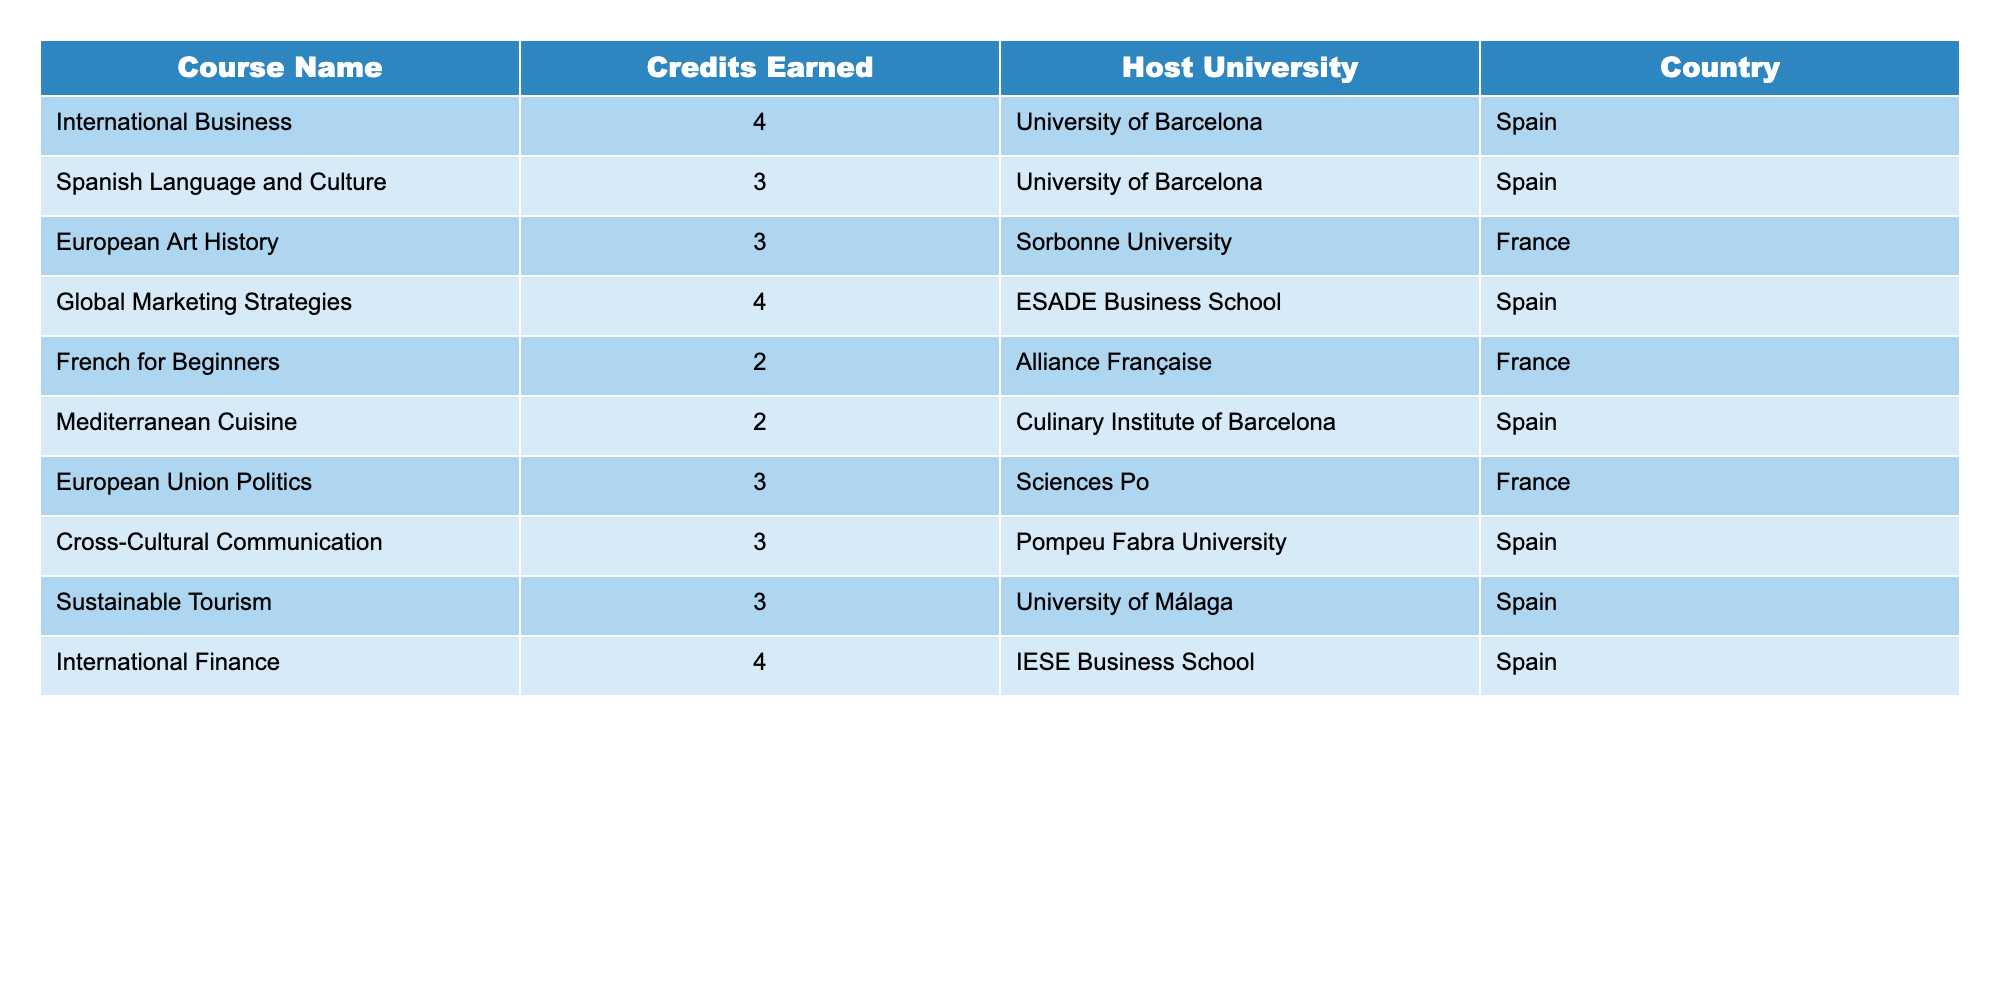What is the total number of credits earned for courses taken in Spain? The table shows courses taken in Spain with their respective credits. The relevant courses are: International Business (4), Spanish Language and Culture (3), Global Marketing Strategies (4), Mediterranean Cuisine (2), International Finance (4). Adding these credits gives: 4 + 3 + 4 + 2 + 4 = 17.
Answer: 17 How many courses were taken at Sciences Po in France? Looking at the table, there is only one course listed under Sciences Po, which is European Union Politics.
Answer: 1 What is the average number of credits earned per course across all courses? To find the average, first sum the credits earned: 4 + 3 + 3 + 4 + 2 + 2 + 3 + 3 + 3 + 4 = 31. There are 10 courses in total. Therefore, the average is 31/10 = 3.1.
Answer: 3.1 Are there any courses that earned 2 credits? The table lists Mediterranean Cuisine and French for Beginners, both of which earned 2 credits. Thus, the answer is yes.
Answer: Yes Which course has the maximum credits earned and what is the value? By examining the credits earned for each course in the table, the highest value listed is 4 credits. The courses that earned this maximum value are International Business, Global Marketing Strategies, and International Finance.
Answer: 4 